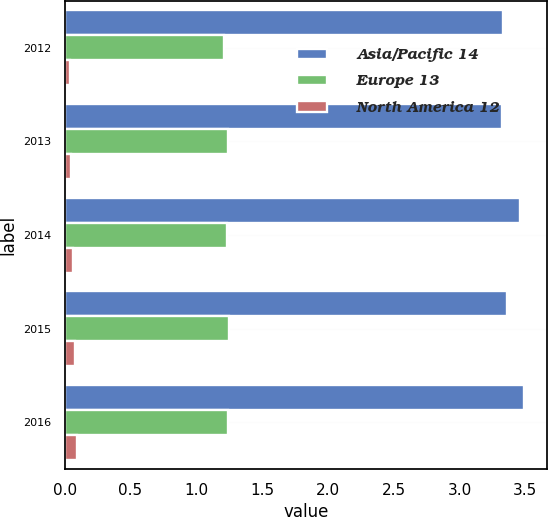Convert chart to OTSL. <chart><loc_0><loc_0><loc_500><loc_500><stacked_bar_chart><ecel><fcel>2012<fcel>2013<fcel>2014<fcel>2015<fcel>2016<nl><fcel>Asia/Pacific 14<fcel>3.33<fcel>3.32<fcel>3.46<fcel>3.36<fcel>3.49<nl><fcel>Europe 13<fcel>1.21<fcel>1.24<fcel>1.23<fcel>1.25<fcel>1.24<nl><fcel>North America 12<fcel>0.04<fcel>0.05<fcel>0.06<fcel>0.08<fcel>0.09<nl></chart> 